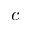Convert formula to latex. <formula><loc_0><loc_0><loc_500><loc_500>c</formula> 